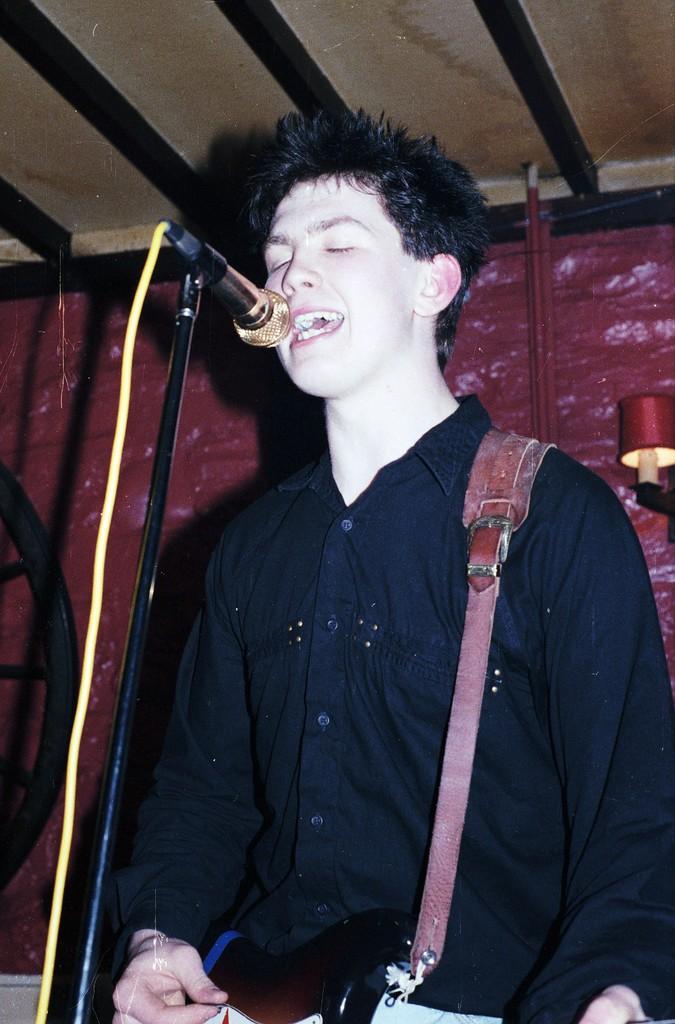Please provide a concise description of this image. As we can see in the image, there is a man singing on mike. 